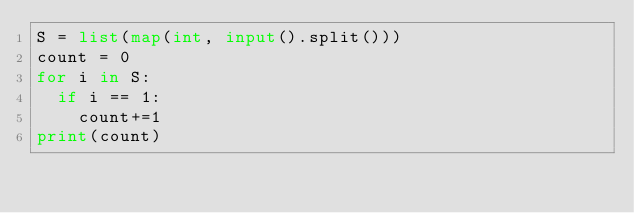Convert code to text. <code><loc_0><loc_0><loc_500><loc_500><_Python_>S = list(map(int, input().split()))
count = 0
for i in S:
  if i == 1:
    count+=1
print(count)</code> 